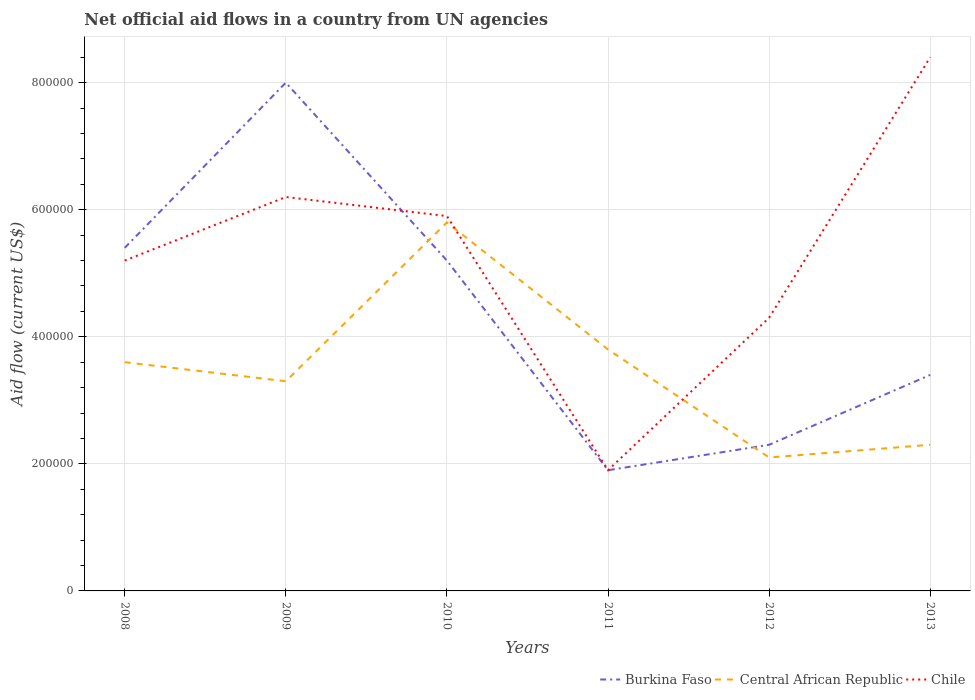Across all years, what is the maximum net official aid flow in Burkina Faso?
Offer a terse response. 1.90e+05. In which year was the net official aid flow in Central African Republic maximum?
Your answer should be very brief. 2012. What is the total net official aid flow in Chile in the graph?
Your answer should be compact. -2.40e+05. What is the difference between the highest and the second highest net official aid flow in Burkina Faso?
Ensure brevity in your answer.  6.10e+05. Is the net official aid flow in Central African Republic strictly greater than the net official aid flow in Burkina Faso over the years?
Offer a terse response. No. How many years are there in the graph?
Provide a succinct answer. 6. What is the difference between two consecutive major ticks on the Y-axis?
Give a very brief answer. 2.00e+05. Are the values on the major ticks of Y-axis written in scientific E-notation?
Provide a succinct answer. No. Does the graph contain grids?
Offer a very short reply. Yes. Where does the legend appear in the graph?
Keep it short and to the point. Bottom right. How many legend labels are there?
Provide a succinct answer. 3. What is the title of the graph?
Ensure brevity in your answer.  Net official aid flows in a country from UN agencies. What is the label or title of the X-axis?
Keep it short and to the point. Years. What is the label or title of the Y-axis?
Offer a terse response. Aid flow (current US$). What is the Aid flow (current US$) in Burkina Faso in 2008?
Provide a short and direct response. 5.40e+05. What is the Aid flow (current US$) of Central African Republic in 2008?
Offer a terse response. 3.60e+05. What is the Aid flow (current US$) of Chile in 2008?
Offer a very short reply. 5.20e+05. What is the Aid flow (current US$) of Chile in 2009?
Your response must be concise. 6.20e+05. What is the Aid flow (current US$) of Burkina Faso in 2010?
Keep it short and to the point. 5.20e+05. What is the Aid flow (current US$) in Central African Republic in 2010?
Offer a terse response. 5.80e+05. What is the Aid flow (current US$) in Chile in 2010?
Offer a very short reply. 5.90e+05. What is the Aid flow (current US$) of Burkina Faso in 2011?
Your response must be concise. 1.90e+05. What is the Aid flow (current US$) in Central African Republic in 2011?
Ensure brevity in your answer.  3.80e+05. What is the Aid flow (current US$) of Central African Republic in 2012?
Offer a terse response. 2.10e+05. What is the Aid flow (current US$) of Burkina Faso in 2013?
Offer a very short reply. 3.40e+05. What is the Aid flow (current US$) of Central African Republic in 2013?
Make the answer very short. 2.30e+05. What is the Aid flow (current US$) of Chile in 2013?
Your answer should be very brief. 8.40e+05. Across all years, what is the maximum Aid flow (current US$) in Burkina Faso?
Offer a very short reply. 8.00e+05. Across all years, what is the maximum Aid flow (current US$) of Central African Republic?
Ensure brevity in your answer.  5.80e+05. Across all years, what is the maximum Aid flow (current US$) in Chile?
Give a very brief answer. 8.40e+05. What is the total Aid flow (current US$) of Burkina Faso in the graph?
Your answer should be compact. 2.62e+06. What is the total Aid flow (current US$) of Central African Republic in the graph?
Offer a very short reply. 2.09e+06. What is the total Aid flow (current US$) of Chile in the graph?
Your response must be concise. 3.19e+06. What is the difference between the Aid flow (current US$) of Burkina Faso in 2008 and that in 2010?
Your answer should be compact. 2.00e+04. What is the difference between the Aid flow (current US$) in Central African Republic in 2008 and that in 2010?
Keep it short and to the point. -2.20e+05. What is the difference between the Aid flow (current US$) of Central African Republic in 2008 and that in 2012?
Offer a very short reply. 1.50e+05. What is the difference between the Aid flow (current US$) in Chile in 2008 and that in 2013?
Make the answer very short. -3.20e+05. What is the difference between the Aid flow (current US$) in Burkina Faso in 2009 and that in 2010?
Ensure brevity in your answer.  2.80e+05. What is the difference between the Aid flow (current US$) of Burkina Faso in 2009 and that in 2011?
Ensure brevity in your answer.  6.10e+05. What is the difference between the Aid flow (current US$) in Burkina Faso in 2009 and that in 2012?
Provide a short and direct response. 5.70e+05. What is the difference between the Aid flow (current US$) in Chile in 2009 and that in 2012?
Your answer should be compact. 1.90e+05. What is the difference between the Aid flow (current US$) of Burkina Faso in 2009 and that in 2013?
Provide a succinct answer. 4.60e+05. What is the difference between the Aid flow (current US$) of Central African Republic in 2010 and that in 2011?
Keep it short and to the point. 2.00e+05. What is the difference between the Aid flow (current US$) of Central African Republic in 2010 and that in 2012?
Offer a terse response. 3.70e+05. What is the difference between the Aid flow (current US$) in Central African Republic in 2010 and that in 2013?
Your answer should be compact. 3.50e+05. What is the difference between the Aid flow (current US$) of Chile in 2010 and that in 2013?
Ensure brevity in your answer.  -2.50e+05. What is the difference between the Aid flow (current US$) in Chile in 2011 and that in 2012?
Provide a short and direct response. -2.40e+05. What is the difference between the Aid flow (current US$) in Chile in 2011 and that in 2013?
Provide a succinct answer. -6.50e+05. What is the difference between the Aid flow (current US$) in Central African Republic in 2012 and that in 2013?
Your answer should be compact. -2.00e+04. What is the difference between the Aid flow (current US$) in Chile in 2012 and that in 2013?
Ensure brevity in your answer.  -4.10e+05. What is the difference between the Aid flow (current US$) in Burkina Faso in 2008 and the Aid flow (current US$) in Chile in 2009?
Your response must be concise. -8.00e+04. What is the difference between the Aid flow (current US$) in Central African Republic in 2008 and the Aid flow (current US$) in Chile in 2009?
Offer a terse response. -2.60e+05. What is the difference between the Aid flow (current US$) in Burkina Faso in 2008 and the Aid flow (current US$) in Central African Republic in 2010?
Offer a very short reply. -4.00e+04. What is the difference between the Aid flow (current US$) in Burkina Faso in 2008 and the Aid flow (current US$) in Chile in 2010?
Give a very brief answer. -5.00e+04. What is the difference between the Aid flow (current US$) in Burkina Faso in 2008 and the Aid flow (current US$) in Central African Republic in 2011?
Your response must be concise. 1.60e+05. What is the difference between the Aid flow (current US$) of Central African Republic in 2008 and the Aid flow (current US$) of Chile in 2011?
Make the answer very short. 1.70e+05. What is the difference between the Aid flow (current US$) in Burkina Faso in 2008 and the Aid flow (current US$) in Central African Republic in 2013?
Give a very brief answer. 3.10e+05. What is the difference between the Aid flow (current US$) of Burkina Faso in 2008 and the Aid flow (current US$) of Chile in 2013?
Your answer should be very brief. -3.00e+05. What is the difference between the Aid flow (current US$) in Central African Republic in 2008 and the Aid flow (current US$) in Chile in 2013?
Provide a short and direct response. -4.80e+05. What is the difference between the Aid flow (current US$) of Burkina Faso in 2009 and the Aid flow (current US$) of Central African Republic in 2012?
Make the answer very short. 5.90e+05. What is the difference between the Aid flow (current US$) in Burkina Faso in 2009 and the Aid flow (current US$) in Chile in 2012?
Your response must be concise. 3.70e+05. What is the difference between the Aid flow (current US$) of Central African Republic in 2009 and the Aid flow (current US$) of Chile in 2012?
Offer a very short reply. -1.00e+05. What is the difference between the Aid flow (current US$) in Burkina Faso in 2009 and the Aid flow (current US$) in Central African Republic in 2013?
Your answer should be very brief. 5.70e+05. What is the difference between the Aid flow (current US$) in Burkina Faso in 2009 and the Aid flow (current US$) in Chile in 2013?
Your answer should be very brief. -4.00e+04. What is the difference between the Aid flow (current US$) of Central African Republic in 2009 and the Aid flow (current US$) of Chile in 2013?
Provide a short and direct response. -5.10e+05. What is the difference between the Aid flow (current US$) of Central African Republic in 2010 and the Aid flow (current US$) of Chile in 2012?
Provide a succinct answer. 1.50e+05. What is the difference between the Aid flow (current US$) of Burkina Faso in 2010 and the Aid flow (current US$) of Chile in 2013?
Make the answer very short. -3.20e+05. What is the difference between the Aid flow (current US$) in Central African Republic in 2010 and the Aid flow (current US$) in Chile in 2013?
Your answer should be compact. -2.60e+05. What is the difference between the Aid flow (current US$) of Burkina Faso in 2011 and the Aid flow (current US$) of Central African Republic in 2012?
Your answer should be compact. -2.00e+04. What is the difference between the Aid flow (current US$) of Burkina Faso in 2011 and the Aid flow (current US$) of Chile in 2012?
Keep it short and to the point. -2.40e+05. What is the difference between the Aid flow (current US$) of Burkina Faso in 2011 and the Aid flow (current US$) of Central African Republic in 2013?
Provide a succinct answer. -4.00e+04. What is the difference between the Aid flow (current US$) in Burkina Faso in 2011 and the Aid flow (current US$) in Chile in 2013?
Provide a short and direct response. -6.50e+05. What is the difference between the Aid flow (current US$) in Central African Republic in 2011 and the Aid flow (current US$) in Chile in 2013?
Provide a succinct answer. -4.60e+05. What is the difference between the Aid flow (current US$) in Burkina Faso in 2012 and the Aid flow (current US$) in Chile in 2013?
Provide a succinct answer. -6.10e+05. What is the difference between the Aid flow (current US$) in Central African Republic in 2012 and the Aid flow (current US$) in Chile in 2013?
Offer a very short reply. -6.30e+05. What is the average Aid flow (current US$) in Burkina Faso per year?
Your answer should be very brief. 4.37e+05. What is the average Aid flow (current US$) of Central African Republic per year?
Keep it short and to the point. 3.48e+05. What is the average Aid flow (current US$) in Chile per year?
Make the answer very short. 5.32e+05. In the year 2008, what is the difference between the Aid flow (current US$) in Burkina Faso and Aid flow (current US$) in Central African Republic?
Provide a succinct answer. 1.80e+05. In the year 2008, what is the difference between the Aid flow (current US$) in Central African Republic and Aid flow (current US$) in Chile?
Provide a succinct answer. -1.60e+05. In the year 2010, what is the difference between the Aid flow (current US$) of Burkina Faso and Aid flow (current US$) of Central African Republic?
Ensure brevity in your answer.  -6.00e+04. In the year 2010, what is the difference between the Aid flow (current US$) of Burkina Faso and Aid flow (current US$) of Chile?
Provide a short and direct response. -7.00e+04. In the year 2011, what is the difference between the Aid flow (current US$) in Central African Republic and Aid flow (current US$) in Chile?
Your answer should be compact. 1.90e+05. In the year 2012, what is the difference between the Aid flow (current US$) of Burkina Faso and Aid flow (current US$) of Central African Republic?
Your answer should be very brief. 2.00e+04. In the year 2012, what is the difference between the Aid flow (current US$) in Burkina Faso and Aid flow (current US$) in Chile?
Offer a very short reply. -2.00e+05. In the year 2012, what is the difference between the Aid flow (current US$) of Central African Republic and Aid flow (current US$) of Chile?
Provide a succinct answer. -2.20e+05. In the year 2013, what is the difference between the Aid flow (current US$) of Burkina Faso and Aid flow (current US$) of Central African Republic?
Provide a succinct answer. 1.10e+05. In the year 2013, what is the difference between the Aid flow (current US$) in Burkina Faso and Aid flow (current US$) in Chile?
Your answer should be compact. -5.00e+05. In the year 2013, what is the difference between the Aid flow (current US$) of Central African Republic and Aid flow (current US$) of Chile?
Offer a very short reply. -6.10e+05. What is the ratio of the Aid flow (current US$) in Burkina Faso in 2008 to that in 2009?
Give a very brief answer. 0.68. What is the ratio of the Aid flow (current US$) of Chile in 2008 to that in 2009?
Offer a very short reply. 0.84. What is the ratio of the Aid flow (current US$) in Central African Republic in 2008 to that in 2010?
Provide a succinct answer. 0.62. What is the ratio of the Aid flow (current US$) in Chile in 2008 to that in 2010?
Make the answer very short. 0.88. What is the ratio of the Aid flow (current US$) of Burkina Faso in 2008 to that in 2011?
Your answer should be very brief. 2.84. What is the ratio of the Aid flow (current US$) of Central African Republic in 2008 to that in 2011?
Ensure brevity in your answer.  0.95. What is the ratio of the Aid flow (current US$) in Chile in 2008 to that in 2011?
Keep it short and to the point. 2.74. What is the ratio of the Aid flow (current US$) in Burkina Faso in 2008 to that in 2012?
Your answer should be compact. 2.35. What is the ratio of the Aid flow (current US$) in Central African Republic in 2008 to that in 2012?
Provide a succinct answer. 1.71. What is the ratio of the Aid flow (current US$) in Chile in 2008 to that in 2012?
Ensure brevity in your answer.  1.21. What is the ratio of the Aid flow (current US$) in Burkina Faso in 2008 to that in 2013?
Your answer should be very brief. 1.59. What is the ratio of the Aid flow (current US$) of Central African Republic in 2008 to that in 2013?
Offer a very short reply. 1.57. What is the ratio of the Aid flow (current US$) of Chile in 2008 to that in 2013?
Ensure brevity in your answer.  0.62. What is the ratio of the Aid flow (current US$) in Burkina Faso in 2009 to that in 2010?
Offer a terse response. 1.54. What is the ratio of the Aid flow (current US$) in Central African Republic in 2009 to that in 2010?
Ensure brevity in your answer.  0.57. What is the ratio of the Aid flow (current US$) of Chile in 2009 to that in 2010?
Offer a very short reply. 1.05. What is the ratio of the Aid flow (current US$) of Burkina Faso in 2009 to that in 2011?
Offer a terse response. 4.21. What is the ratio of the Aid flow (current US$) of Central African Republic in 2009 to that in 2011?
Your answer should be very brief. 0.87. What is the ratio of the Aid flow (current US$) of Chile in 2009 to that in 2011?
Your answer should be very brief. 3.26. What is the ratio of the Aid flow (current US$) in Burkina Faso in 2009 to that in 2012?
Make the answer very short. 3.48. What is the ratio of the Aid flow (current US$) in Central African Republic in 2009 to that in 2012?
Ensure brevity in your answer.  1.57. What is the ratio of the Aid flow (current US$) in Chile in 2009 to that in 2012?
Offer a very short reply. 1.44. What is the ratio of the Aid flow (current US$) in Burkina Faso in 2009 to that in 2013?
Provide a short and direct response. 2.35. What is the ratio of the Aid flow (current US$) in Central African Republic in 2009 to that in 2013?
Offer a very short reply. 1.43. What is the ratio of the Aid flow (current US$) of Chile in 2009 to that in 2013?
Offer a very short reply. 0.74. What is the ratio of the Aid flow (current US$) in Burkina Faso in 2010 to that in 2011?
Your response must be concise. 2.74. What is the ratio of the Aid flow (current US$) in Central African Republic in 2010 to that in 2011?
Keep it short and to the point. 1.53. What is the ratio of the Aid flow (current US$) of Chile in 2010 to that in 2011?
Make the answer very short. 3.11. What is the ratio of the Aid flow (current US$) of Burkina Faso in 2010 to that in 2012?
Offer a terse response. 2.26. What is the ratio of the Aid flow (current US$) of Central African Republic in 2010 to that in 2012?
Offer a terse response. 2.76. What is the ratio of the Aid flow (current US$) in Chile in 2010 to that in 2012?
Provide a succinct answer. 1.37. What is the ratio of the Aid flow (current US$) of Burkina Faso in 2010 to that in 2013?
Ensure brevity in your answer.  1.53. What is the ratio of the Aid flow (current US$) of Central African Republic in 2010 to that in 2013?
Make the answer very short. 2.52. What is the ratio of the Aid flow (current US$) in Chile in 2010 to that in 2013?
Make the answer very short. 0.7. What is the ratio of the Aid flow (current US$) in Burkina Faso in 2011 to that in 2012?
Offer a very short reply. 0.83. What is the ratio of the Aid flow (current US$) of Central African Republic in 2011 to that in 2012?
Keep it short and to the point. 1.81. What is the ratio of the Aid flow (current US$) in Chile in 2011 to that in 2012?
Provide a succinct answer. 0.44. What is the ratio of the Aid flow (current US$) of Burkina Faso in 2011 to that in 2013?
Keep it short and to the point. 0.56. What is the ratio of the Aid flow (current US$) of Central African Republic in 2011 to that in 2013?
Ensure brevity in your answer.  1.65. What is the ratio of the Aid flow (current US$) in Chile in 2011 to that in 2013?
Provide a succinct answer. 0.23. What is the ratio of the Aid flow (current US$) of Burkina Faso in 2012 to that in 2013?
Provide a succinct answer. 0.68. What is the ratio of the Aid flow (current US$) in Chile in 2012 to that in 2013?
Your answer should be very brief. 0.51. What is the difference between the highest and the second highest Aid flow (current US$) in Burkina Faso?
Offer a terse response. 2.60e+05. What is the difference between the highest and the lowest Aid flow (current US$) of Central African Republic?
Keep it short and to the point. 3.70e+05. What is the difference between the highest and the lowest Aid flow (current US$) in Chile?
Your answer should be compact. 6.50e+05. 